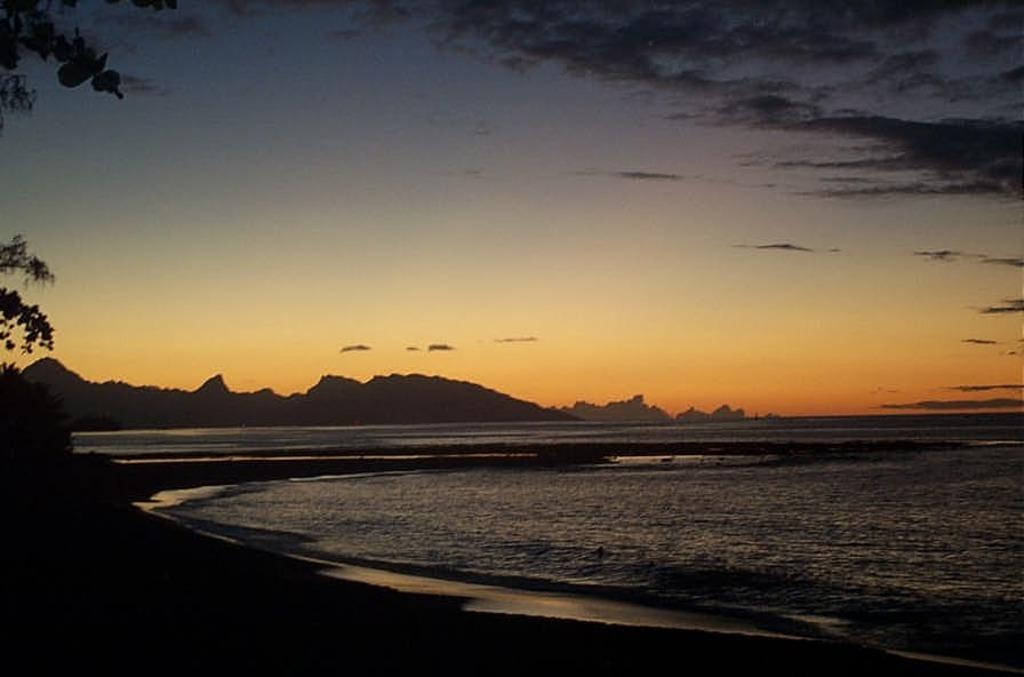What is one of the natural elements present in the image? There is water in the image. What type of vegetation can be seen in the image? There are trees in the image. What geographical feature is visible in the image? There are mountains in the image. What part of the environment is visible in the image? The sky is visible in the image. Can you make an assumption about the time of day based on the image? The image may have been taken in the evening, as the sky appears to be darker. Can you tell me how many lamps are on the mountains in the image? There are no lamps present in the image; it features natural elements such as water, trees, mountains, and the sky. What type of conversation is the grandfather having with the trees in the image? There is no grandfather or conversation present in the image; it features natural elements and a possible evening setting. 